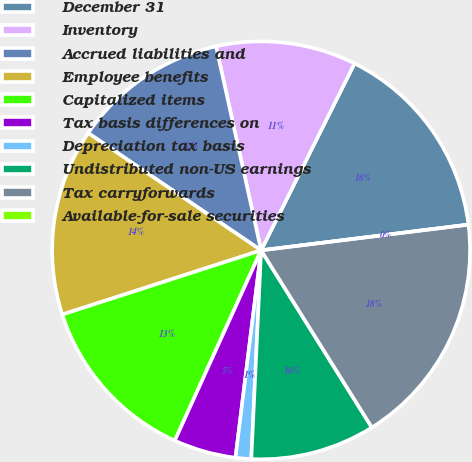Convert chart. <chart><loc_0><loc_0><loc_500><loc_500><pie_chart><fcel>December 31<fcel>Inventory<fcel>Accrued liabilities and<fcel>Employee benefits<fcel>Capitalized items<fcel>Tax basis differences on<fcel>Depreciation tax basis<fcel>Undistributed non-US earnings<fcel>Tax carryforwards<fcel>Available-for-sale securities<nl><fcel>15.66%<fcel>10.84%<fcel>12.05%<fcel>14.46%<fcel>13.25%<fcel>4.82%<fcel>1.21%<fcel>9.64%<fcel>18.07%<fcel>0.0%<nl></chart> 